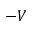Convert formula to latex. <formula><loc_0><loc_0><loc_500><loc_500>- V</formula> 